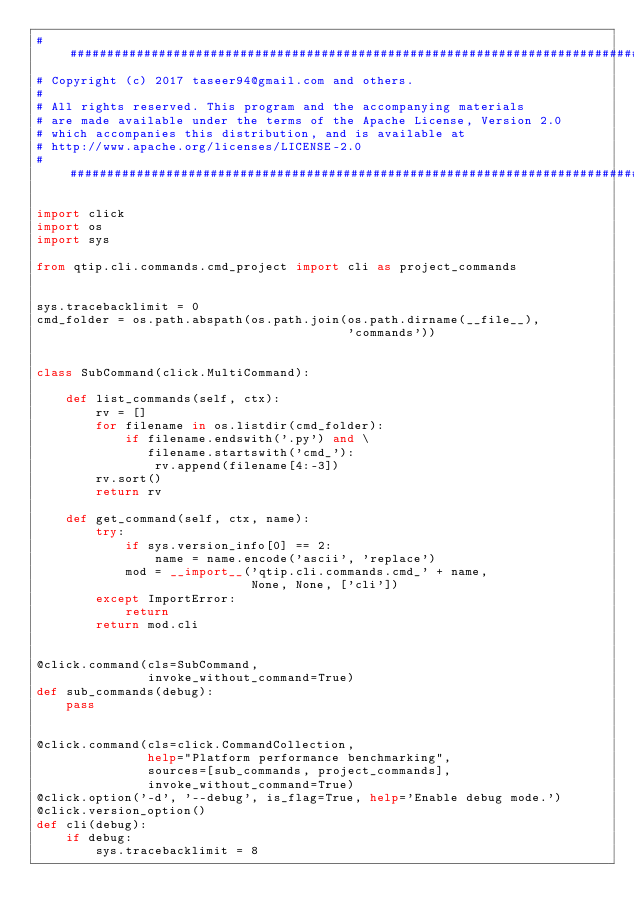<code> <loc_0><loc_0><loc_500><loc_500><_Python_>##############################################################################
# Copyright (c) 2017 taseer94@gmail.com and others.
#
# All rights reserved. This program and the accompanying materials
# are made available under the terms of the Apache License, Version 2.0
# which accompanies this distribution, and is available at
# http://www.apache.org/licenses/LICENSE-2.0
##############################################################################

import click
import os
import sys

from qtip.cli.commands.cmd_project import cli as project_commands


sys.tracebacklimit = 0
cmd_folder = os.path.abspath(os.path.join(os.path.dirname(__file__),
                                          'commands'))


class SubCommand(click.MultiCommand):

    def list_commands(self, ctx):
        rv = []
        for filename in os.listdir(cmd_folder):
            if filename.endswith('.py') and \
               filename.startswith('cmd_'):
                rv.append(filename[4:-3])
        rv.sort()
        return rv

    def get_command(self, ctx, name):
        try:
            if sys.version_info[0] == 2:
                name = name.encode('ascii', 'replace')
            mod = __import__('qtip.cli.commands.cmd_' + name,
                             None, None, ['cli'])
        except ImportError:
            return
        return mod.cli


@click.command(cls=SubCommand,
               invoke_without_command=True)
def sub_commands(debug):
    pass


@click.command(cls=click.CommandCollection,
               help="Platform performance benchmarking",
               sources=[sub_commands, project_commands],
               invoke_without_command=True)
@click.option('-d', '--debug', is_flag=True, help='Enable debug mode.')
@click.version_option()
def cli(debug):
    if debug:
        sys.tracebacklimit = 8
</code> 